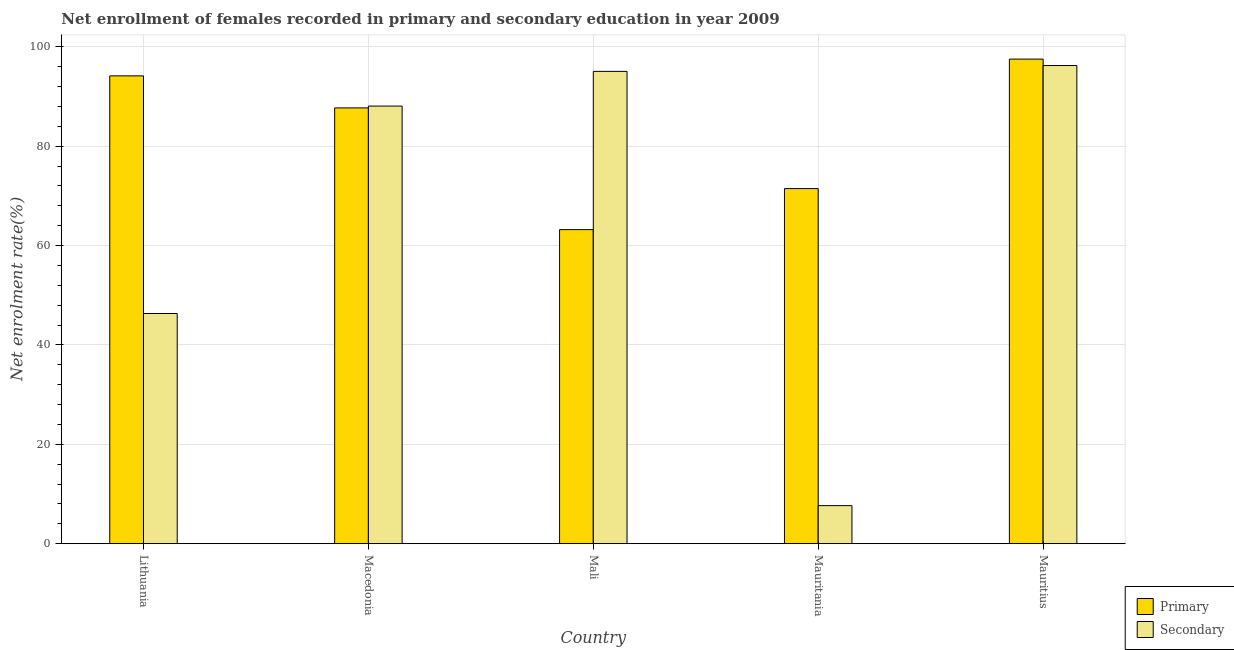How many different coloured bars are there?
Provide a short and direct response. 2. How many groups of bars are there?
Ensure brevity in your answer.  5. How many bars are there on the 5th tick from the left?
Your response must be concise. 2. What is the label of the 4th group of bars from the left?
Provide a succinct answer. Mauritania. What is the enrollment rate in secondary education in Mali?
Offer a very short reply. 95.05. Across all countries, what is the maximum enrollment rate in primary education?
Provide a short and direct response. 97.52. Across all countries, what is the minimum enrollment rate in primary education?
Offer a terse response. 63.21. In which country was the enrollment rate in secondary education maximum?
Offer a terse response. Mauritius. In which country was the enrollment rate in secondary education minimum?
Ensure brevity in your answer.  Mauritania. What is the total enrollment rate in secondary education in the graph?
Your answer should be very brief. 333.35. What is the difference between the enrollment rate in secondary education in Lithuania and that in Mali?
Offer a very short reply. -48.72. What is the difference between the enrollment rate in secondary education in Mali and the enrollment rate in primary education in Mauritius?
Provide a succinct answer. -2.47. What is the average enrollment rate in secondary education per country?
Provide a succinct answer. 66.67. What is the difference between the enrollment rate in primary education and enrollment rate in secondary education in Mauritius?
Provide a short and direct response. 1.29. In how many countries, is the enrollment rate in secondary education greater than 8 %?
Your answer should be compact. 4. What is the ratio of the enrollment rate in secondary education in Lithuania to that in Mauritius?
Keep it short and to the point. 0.48. Is the enrollment rate in primary education in Lithuania less than that in Macedonia?
Your answer should be compact. No. Is the difference between the enrollment rate in secondary education in Macedonia and Mali greater than the difference between the enrollment rate in primary education in Macedonia and Mali?
Your answer should be very brief. No. What is the difference between the highest and the second highest enrollment rate in secondary education?
Offer a terse response. 1.17. What is the difference between the highest and the lowest enrollment rate in primary education?
Ensure brevity in your answer.  34.31. In how many countries, is the enrollment rate in secondary education greater than the average enrollment rate in secondary education taken over all countries?
Give a very brief answer. 3. Is the sum of the enrollment rate in secondary education in Lithuania and Mauritania greater than the maximum enrollment rate in primary education across all countries?
Your response must be concise. No. What does the 2nd bar from the left in Lithuania represents?
Offer a very short reply. Secondary. What does the 2nd bar from the right in Mali represents?
Ensure brevity in your answer.  Primary. How many countries are there in the graph?
Your response must be concise. 5. What is the difference between two consecutive major ticks on the Y-axis?
Make the answer very short. 20. Does the graph contain any zero values?
Keep it short and to the point. No. Does the graph contain grids?
Your answer should be compact. Yes. How are the legend labels stacked?
Keep it short and to the point. Vertical. What is the title of the graph?
Ensure brevity in your answer.  Net enrollment of females recorded in primary and secondary education in year 2009. What is the label or title of the X-axis?
Make the answer very short. Country. What is the label or title of the Y-axis?
Your answer should be compact. Net enrolment rate(%). What is the Net enrolment rate(%) of Primary in Lithuania?
Make the answer very short. 94.15. What is the Net enrolment rate(%) in Secondary in Lithuania?
Provide a short and direct response. 46.33. What is the Net enrolment rate(%) in Primary in Macedonia?
Provide a short and direct response. 87.7. What is the Net enrolment rate(%) in Secondary in Macedonia?
Make the answer very short. 88.07. What is the Net enrolment rate(%) in Primary in Mali?
Provide a short and direct response. 63.21. What is the Net enrolment rate(%) of Secondary in Mali?
Provide a short and direct response. 95.05. What is the Net enrolment rate(%) in Primary in Mauritania?
Keep it short and to the point. 71.47. What is the Net enrolment rate(%) in Secondary in Mauritania?
Keep it short and to the point. 7.67. What is the Net enrolment rate(%) of Primary in Mauritius?
Your answer should be very brief. 97.52. What is the Net enrolment rate(%) of Secondary in Mauritius?
Make the answer very short. 96.23. Across all countries, what is the maximum Net enrolment rate(%) of Primary?
Offer a terse response. 97.52. Across all countries, what is the maximum Net enrolment rate(%) of Secondary?
Keep it short and to the point. 96.23. Across all countries, what is the minimum Net enrolment rate(%) of Primary?
Provide a succinct answer. 63.21. Across all countries, what is the minimum Net enrolment rate(%) of Secondary?
Provide a succinct answer. 7.67. What is the total Net enrolment rate(%) of Primary in the graph?
Give a very brief answer. 414.06. What is the total Net enrolment rate(%) in Secondary in the graph?
Give a very brief answer. 333.35. What is the difference between the Net enrolment rate(%) in Primary in Lithuania and that in Macedonia?
Provide a short and direct response. 6.45. What is the difference between the Net enrolment rate(%) in Secondary in Lithuania and that in Macedonia?
Provide a short and direct response. -41.74. What is the difference between the Net enrolment rate(%) in Primary in Lithuania and that in Mali?
Your response must be concise. 30.94. What is the difference between the Net enrolment rate(%) in Secondary in Lithuania and that in Mali?
Your answer should be very brief. -48.72. What is the difference between the Net enrolment rate(%) of Primary in Lithuania and that in Mauritania?
Make the answer very short. 22.68. What is the difference between the Net enrolment rate(%) in Secondary in Lithuania and that in Mauritania?
Ensure brevity in your answer.  38.66. What is the difference between the Net enrolment rate(%) in Primary in Lithuania and that in Mauritius?
Ensure brevity in your answer.  -3.37. What is the difference between the Net enrolment rate(%) in Secondary in Lithuania and that in Mauritius?
Your answer should be compact. -49.9. What is the difference between the Net enrolment rate(%) in Primary in Macedonia and that in Mali?
Keep it short and to the point. 24.49. What is the difference between the Net enrolment rate(%) of Secondary in Macedonia and that in Mali?
Offer a terse response. -6.98. What is the difference between the Net enrolment rate(%) of Primary in Macedonia and that in Mauritania?
Offer a terse response. 16.23. What is the difference between the Net enrolment rate(%) of Secondary in Macedonia and that in Mauritania?
Provide a succinct answer. 80.4. What is the difference between the Net enrolment rate(%) of Primary in Macedonia and that in Mauritius?
Ensure brevity in your answer.  -9.82. What is the difference between the Net enrolment rate(%) of Secondary in Macedonia and that in Mauritius?
Give a very brief answer. -8.16. What is the difference between the Net enrolment rate(%) of Primary in Mali and that in Mauritania?
Offer a very short reply. -8.26. What is the difference between the Net enrolment rate(%) of Secondary in Mali and that in Mauritania?
Provide a succinct answer. 87.38. What is the difference between the Net enrolment rate(%) of Primary in Mali and that in Mauritius?
Your response must be concise. -34.31. What is the difference between the Net enrolment rate(%) of Secondary in Mali and that in Mauritius?
Your response must be concise. -1.17. What is the difference between the Net enrolment rate(%) in Primary in Mauritania and that in Mauritius?
Give a very brief answer. -26.05. What is the difference between the Net enrolment rate(%) of Secondary in Mauritania and that in Mauritius?
Offer a terse response. -88.55. What is the difference between the Net enrolment rate(%) in Primary in Lithuania and the Net enrolment rate(%) in Secondary in Macedonia?
Provide a short and direct response. 6.08. What is the difference between the Net enrolment rate(%) of Primary in Lithuania and the Net enrolment rate(%) of Secondary in Mali?
Your response must be concise. -0.9. What is the difference between the Net enrolment rate(%) in Primary in Lithuania and the Net enrolment rate(%) in Secondary in Mauritania?
Offer a terse response. 86.48. What is the difference between the Net enrolment rate(%) in Primary in Lithuania and the Net enrolment rate(%) in Secondary in Mauritius?
Offer a terse response. -2.08. What is the difference between the Net enrolment rate(%) in Primary in Macedonia and the Net enrolment rate(%) in Secondary in Mali?
Provide a short and direct response. -7.35. What is the difference between the Net enrolment rate(%) in Primary in Macedonia and the Net enrolment rate(%) in Secondary in Mauritania?
Offer a very short reply. 80.03. What is the difference between the Net enrolment rate(%) in Primary in Macedonia and the Net enrolment rate(%) in Secondary in Mauritius?
Offer a terse response. -8.52. What is the difference between the Net enrolment rate(%) of Primary in Mali and the Net enrolment rate(%) of Secondary in Mauritania?
Give a very brief answer. 55.54. What is the difference between the Net enrolment rate(%) of Primary in Mali and the Net enrolment rate(%) of Secondary in Mauritius?
Your answer should be very brief. -33.02. What is the difference between the Net enrolment rate(%) in Primary in Mauritania and the Net enrolment rate(%) in Secondary in Mauritius?
Your answer should be compact. -24.76. What is the average Net enrolment rate(%) in Primary per country?
Your answer should be compact. 82.81. What is the average Net enrolment rate(%) in Secondary per country?
Offer a very short reply. 66.67. What is the difference between the Net enrolment rate(%) in Primary and Net enrolment rate(%) in Secondary in Lithuania?
Offer a very short reply. 47.82. What is the difference between the Net enrolment rate(%) in Primary and Net enrolment rate(%) in Secondary in Macedonia?
Provide a short and direct response. -0.37. What is the difference between the Net enrolment rate(%) in Primary and Net enrolment rate(%) in Secondary in Mali?
Give a very brief answer. -31.84. What is the difference between the Net enrolment rate(%) in Primary and Net enrolment rate(%) in Secondary in Mauritania?
Your answer should be very brief. 63.8. What is the difference between the Net enrolment rate(%) in Primary and Net enrolment rate(%) in Secondary in Mauritius?
Provide a succinct answer. 1.29. What is the ratio of the Net enrolment rate(%) of Primary in Lithuania to that in Macedonia?
Your answer should be very brief. 1.07. What is the ratio of the Net enrolment rate(%) in Secondary in Lithuania to that in Macedonia?
Offer a terse response. 0.53. What is the ratio of the Net enrolment rate(%) in Primary in Lithuania to that in Mali?
Offer a very short reply. 1.49. What is the ratio of the Net enrolment rate(%) in Secondary in Lithuania to that in Mali?
Make the answer very short. 0.49. What is the ratio of the Net enrolment rate(%) in Primary in Lithuania to that in Mauritania?
Provide a succinct answer. 1.32. What is the ratio of the Net enrolment rate(%) in Secondary in Lithuania to that in Mauritania?
Offer a terse response. 6.04. What is the ratio of the Net enrolment rate(%) in Primary in Lithuania to that in Mauritius?
Your answer should be compact. 0.97. What is the ratio of the Net enrolment rate(%) of Secondary in Lithuania to that in Mauritius?
Ensure brevity in your answer.  0.48. What is the ratio of the Net enrolment rate(%) in Primary in Macedonia to that in Mali?
Keep it short and to the point. 1.39. What is the ratio of the Net enrolment rate(%) of Secondary in Macedonia to that in Mali?
Make the answer very short. 0.93. What is the ratio of the Net enrolment rate(%) in Primary in Macedonia to that in Mauritania?
Ensure brevity in your answer.  1.23. What is the ratio of the Net enrolment rate(%) of Secondary in Macedonia to that in Mauritania?
Your answer should be compact. 11.48. What is the ratio of the Net enrolment rate(%) in Primary in Macedonia to that in Mauritius?
Provide a short and direct response. 0.9. What is the ratio of the Net enrolment rate(%) in Secondary in Macedonia to that in Mauritius?
Keep it short and to the point. 0.92. What is the ratio of the Net enrolment rate(%) in Primary in Mali to that in Mauritania?
Your response must be concise. 0.88. What is the ratio of the Net enrolment rate(%) of Secondary in Mali to that in Mauritania?
Provide a short and direct response. 12.39. What is the ratio of the Net enrolment rate(%) of Primary in Mali to that in Mauritius?
Offer a terse response. 0.65. What is the ratio of the Net enrolment rate(%) in Primary in Mauritania to that in Mauritius?
Your answer should be compact. 0.73. What is the ratio of the Net enrolment rate(%) of Secondary in Mauritania to that in Mauritius?
Offer a very short reply. 0.08. What is the difference between the highest and the second highest Net enrolment rate(%) in Primary?
Make the answer very short. 3.37. What is the difference between the highest and the second highest Net enrolment rate(%) in Secondary?
Give a very brief answer. 1.17. What is the difference between the highest and the lowest Net enrolment rate(%) of Primary?
Make the answer very short. 34.31. What is the difference between the highest and the lowest Net enrolment rate(%) of Secondary?
Provide a short and direct response. 88.55. 